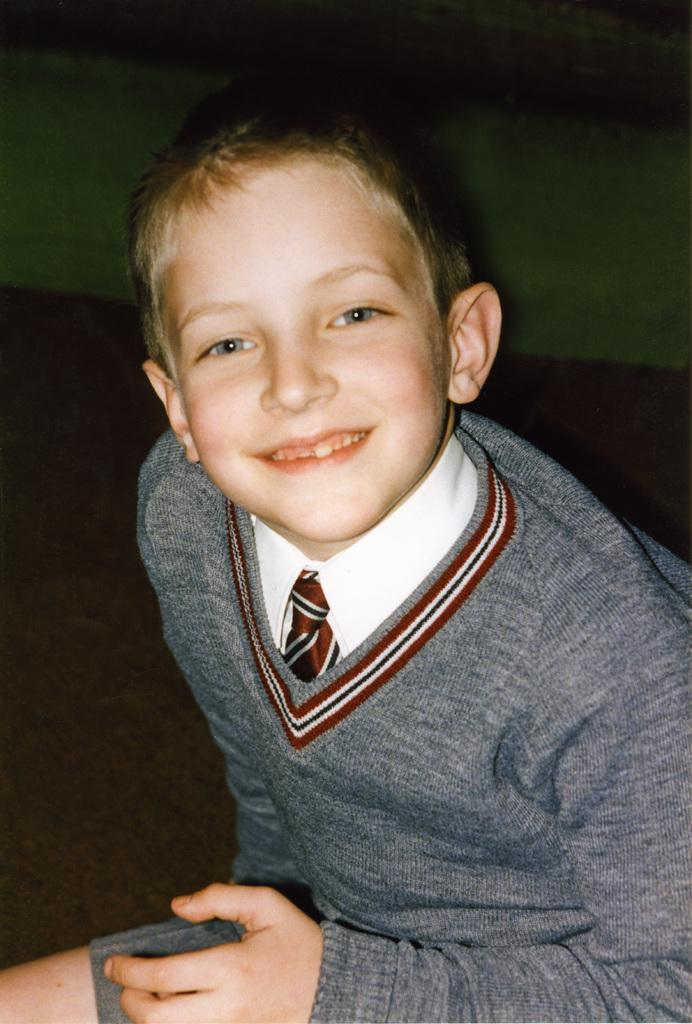Who is the main subject in the image? There is a boy in the image. What is the boy doing in the image? The boy is sitting. What color is the shirt the boy is wearing? The boy is wearing a white color shirt. What color is the sweatshirt the boy is wearing? The boy is wearing a grey color sweatshirt. What expression does the boy have in the image? The boy is smiling. What can be observed about the background of the image? The background of the image is dark. What type of honey can be seen dripping from the rock in the image? There is no honey or rock present in the image; it features a boy sitting and smiling. 